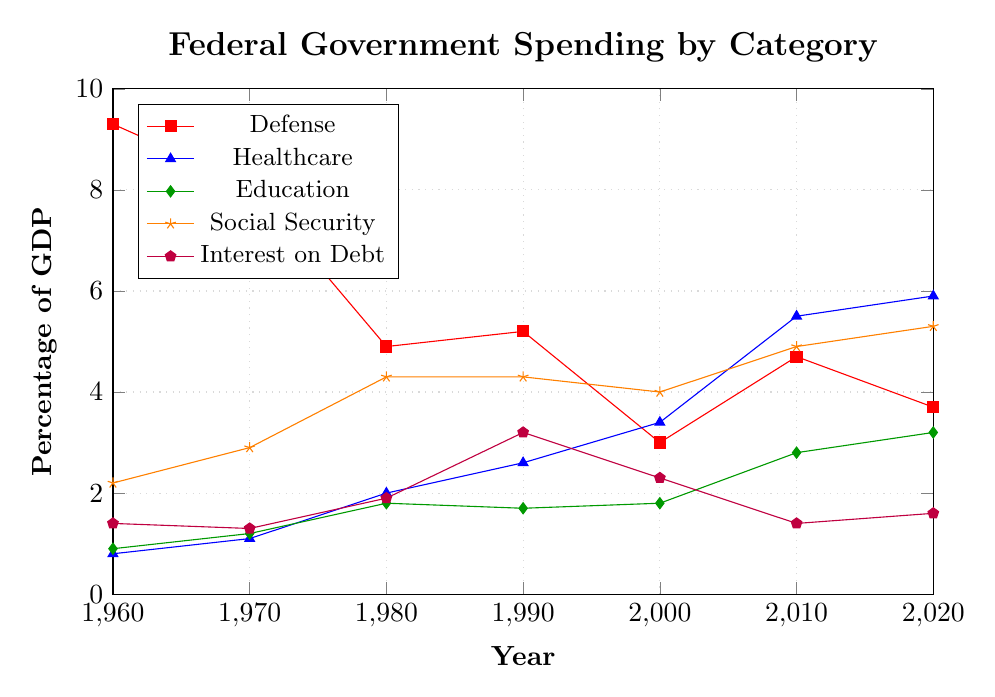Which category had the highest spending as a percentage of GDP in 1960? In the 1960 data, the categories are compared: Defense (9.3%), Healthcare (0.8%), Education (0.9%), Social Security (2.2%), and Interest on Debt (1.4%). Defense has the highest spending.
Answer: Defense Has healthcare spending as a percentage of GDP increased or decreased from 1960 to 2020? Compare healthcare spending in 1960 (0.8%) with that in 2020 (5.9%). It has increased.
Answer: Increased In which year did Social Security spending first surpass 4% of GDP? Look for the first year where Social Security spending is above 4%. In 1980, it reached 4.3%.
Answer: 1980 What was the difference in defense spending as a percentage of GDP between 1960 and 2020? Compare defense spending in 1960 (9.3%) and 2020 (3.7%). The difference is 9.3 - 3.7 = 5.6%.
Answer: 5.6% Which category shows the most consistent increase in spending from 1960 to 2020? By analyzing trends, Healthcare spending steadily rises from 0.8% in 1960 to 5.9% in 2020, showing a consistent increase.
Answer: Healthcare What was the percentage of GDP spent on Education in 2010, and how does it compare to 2000? Education spending in 2010 is 2.8%, and in 2000, it is 1.8%. The comparison shows it increased by 2.8 - 1.8 = 1%.
Answer: 2.8%, increased by 1% Which year had the lowest interest on debt as a percentage of GDP? Check the data: 1960 (1.4%), 1970 (1.3%), 1980 (1.9%), 1990 (3.2%), 2000 (2.3%), 2010 (1.4%), 2020 (1.6%). The lowest is in 1970 at 1.3%.
Answer: 1970 Between 1980 and 2020, how much has Social Security spending changed as a percentage of GDP? Compare Social Security spending in 1980 (4.3%) and 2020 (5.3%). The change is 5.3 - 4.3 = 1%.
Answer: 1% Which category saw a decrease in spending as a percentage of GDP from 2010 to 2020? From 2010 to 2020, compare the spending of each category: Defense decreased from 4.7% to 3.7%. Other categories increased or remained almost stable.
Answer: Defense Did any category reach a spending level of 10% of GDP in any given year? Analyze the maximum values for each category: Defense (9.3% in 1960), Healthcare (5.9% in 2020), Education (3.2% in 2020), Social Security (5.3% in 2020), and Interest on Debt (3.2% in 1990). None reached 10%.
Answer: No 